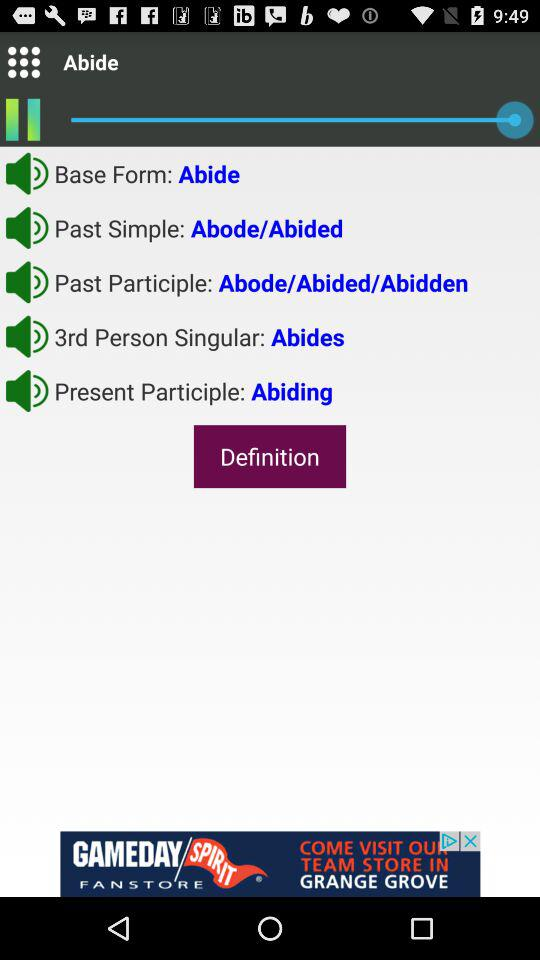What is the past simple of "Abide"? The past simple is abode and abided. 